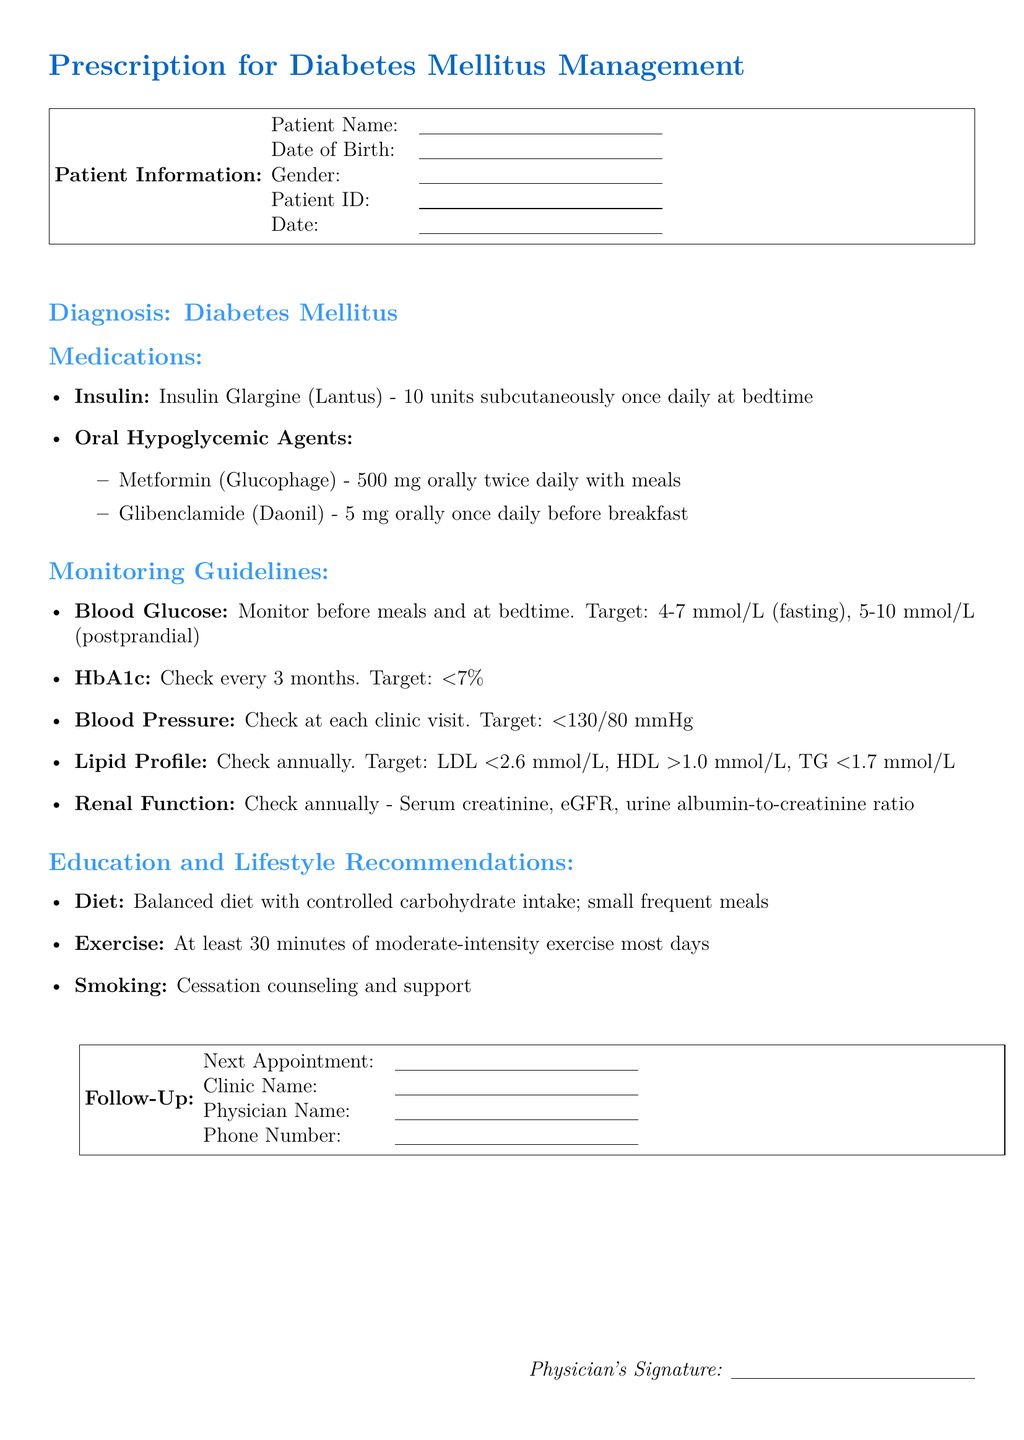What is the patient's medication for insulin? The patient's medication for insulin is listed as Insulin Glargine (Lantus) - 10 units subcutaneously once daily at bedtime.
Answer: Insulin Glargine (Lantus) What is the dosage of Metformin? The dosage of Metformin is specified in the document as 500 mg orally twice daily with meals.
Answer: 500 mg orally twice daily How often should HbA1c be checked? The document states that HbA1c should be checked every 3 months.
Answer: every 3 months What is the target for fasting blood glucose? The document mentions that the target for fasting blood glucose is 4-7 mmol/L.
Answer: 4-7 mmol/L What dietary recommendation is given? The dietary recommendation included in the document advises a balanced diet with controlled carbohydrate intake; small frequent meals.
Answer: balanced diet with controlled carbohydrate intake; small frequent meals How much exercise is recommended? The document recommends at least 30 minutes of moderate-intensity exercise most days.
Answer: 30 minutes of moderate-intensity exercise most days What is the target blood pressure? The target blood pressure specified in the document is <130/80 mmHg.
Answer: <130/80 mmHg When is the next appointment? The date for the next appointment is to be filled in the patient information area, which is currently blank.
Answer: (To be filled in) What should be monitored annually? The document indicates that renal function, including serum creatinine, eGFR, and urine albumin-to-creatinine ratio, should be checked annually.
Answer: renal function, serum creatinine, eGFR, urine albumin-to-creatinine ratio 